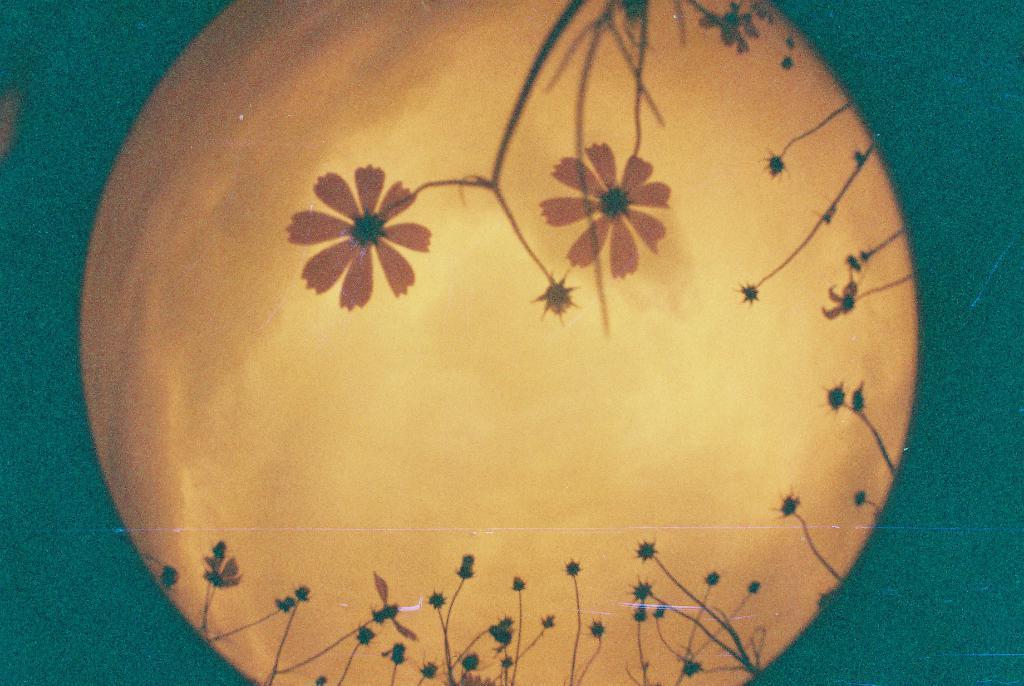Describe this image in one or two sentences. In this picture as some painting with some flowers and plants. In the background, we can see green color. 